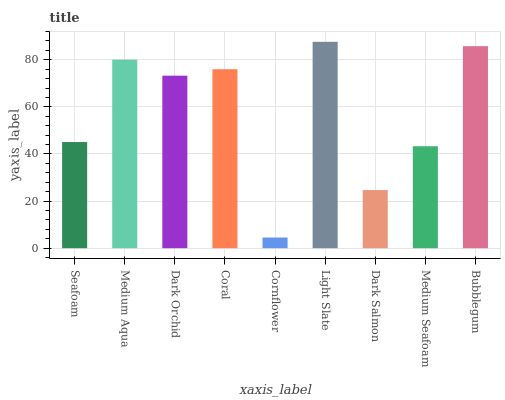Is Cornflower the minimum?
Answer yes or no. Yes. Is Light Slate the maximum?
Answer yes or no. Yes. Is Medium Aqua the minimum?
Answer yes or no. No. Is Medium Aqua the maximum?
Answer yes or no. No. Is Medium Aqua greater than Seafoam?
Answer yes or no. Yes. Is Seafoam less than Medium Aqua?
Answer yes or no. Yes. Is Seafoam greater than Medium Aqua?
Answer yes or no. No. Is Medium Aqua less than Seafoam?
Answer yes or no. No. Is Dark Orchid the high median?
Answer yes or no. Yes. Is Dark Orchid the low median?
Answer yes or no. Yes. Is Seafoam the high median?
Answer yes or no. No. Is Bubblegum the low median?
Answer yes or no. No. 